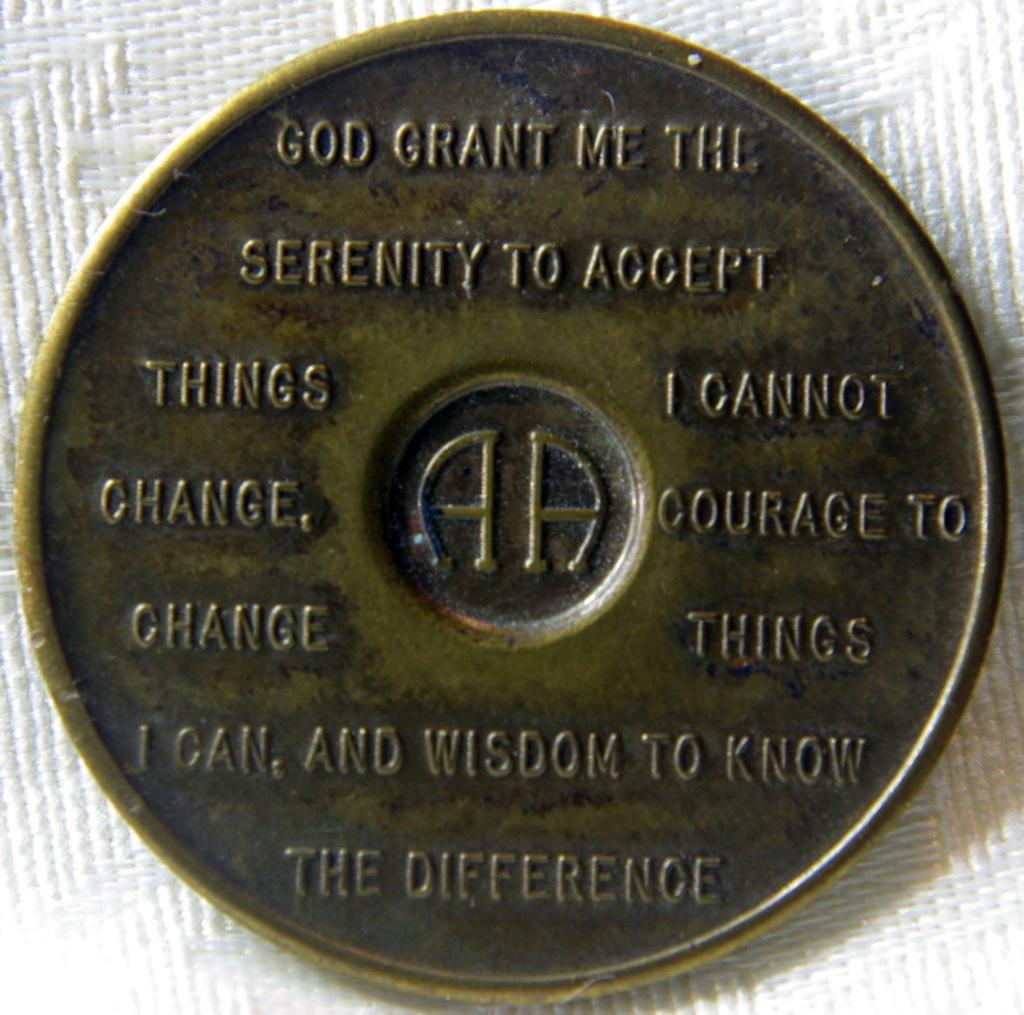What object is the main focus of the image? There is a coin in the image. What can be seen on the surface of the coin? There are names printed on the coin. What is the color of the surface the coin is placed on? The coin is on a white surface. What type of songs can be heard playing in the background of the image? There is no indication of any songs or background music in the image, as it only features a coin on a white surface. 